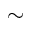<formula> <loc_0><loc_0><loc_500><loc_500>\sim</formula> 